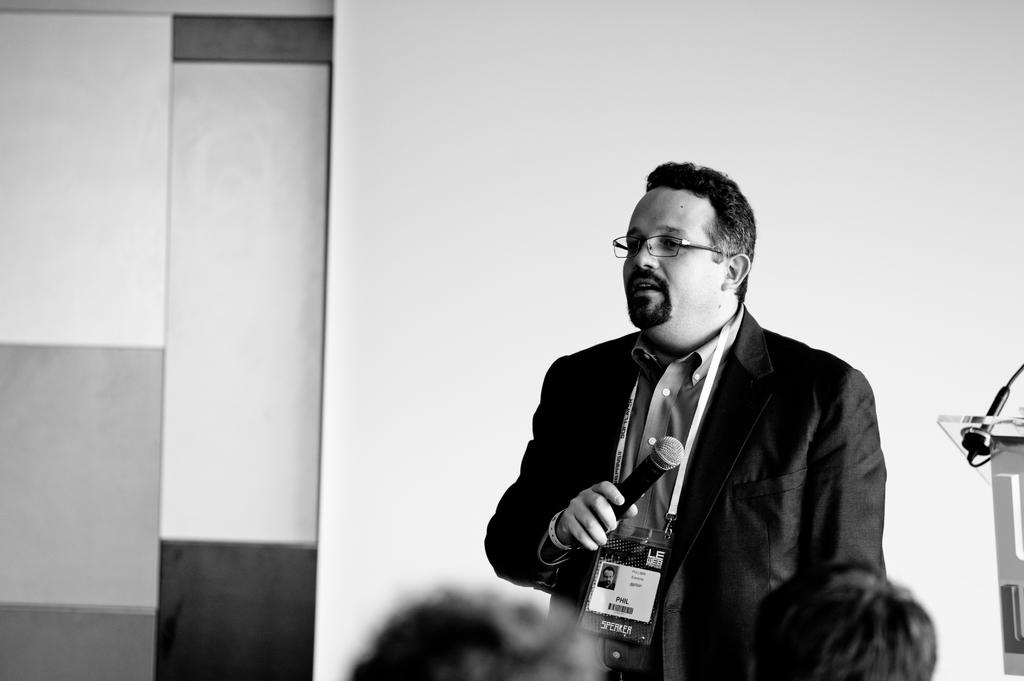What is the person in the image doing? The person is standing in the image. What is the person wearing? The person is wearing a blazer. What object is the person holding? The person is holding a microphone. What can be seen on the person's chest? The person has an identity card. What is visible in the background of the image? There is a wall and a podium in the background of the image. What type of zebra can be seen grazing near the podium in the image? There is no zebra present in the image; it only features a person standing, wearing a blazer, holding a microphone, and having an identity card, along with a wall and a podium in the background. 